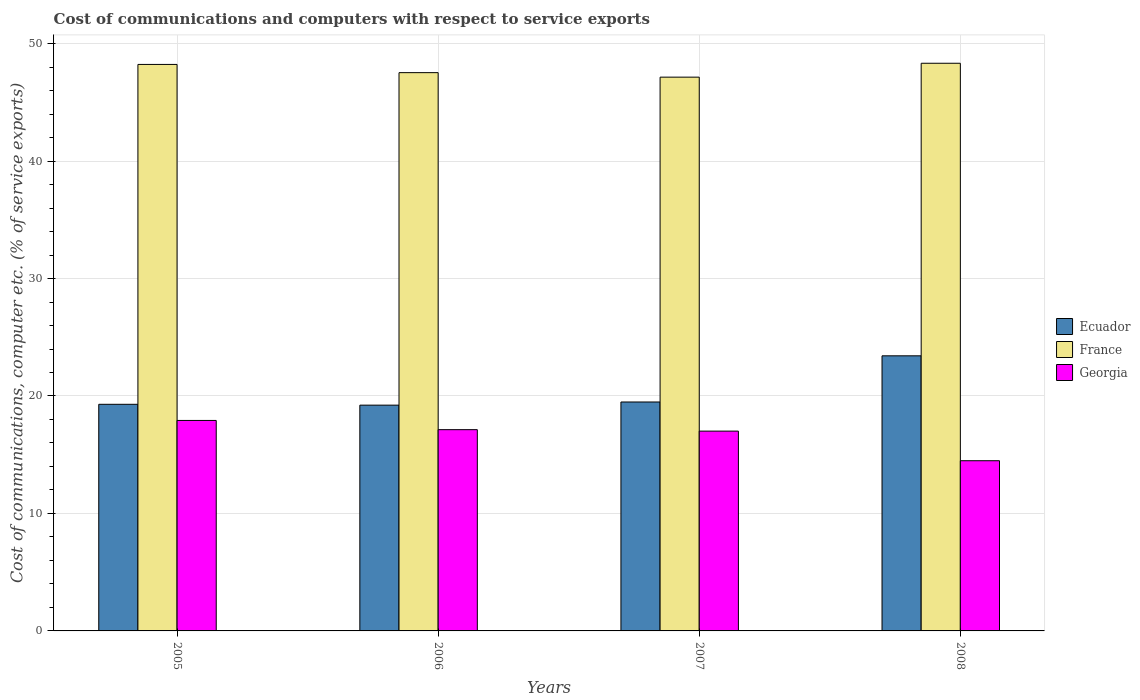How many different coloured bars are there?
Ensure brevity in your answer.  3. How many groups of bars are there?
Make the answer very short. 4. Are the number of bars per tick equal to the number of legend labels?
Offer a very short reply. Yes. In how many cases, is the number of bars for a given year not equal to the number of legend labels?
Make the answer very short. 0. What is the cost of communications and computers in Georgia in 2007?
Offer a very short reply. 17.01. Across all years, what is the maximum cost of communications and computers in Georgia?
Provide a short and direct response. 17.92. Across all years, what is the minimum cost of communications and computers in France?
Offer a terse response. 47.14. In which year was the cost of communications and computers in Ecuador minimum?
Offer a terse response. 2006. What is the total cost of communications and computers in Ecuador in the graph?
Your answer should be compact. 81.42. What is the difference between the cost of communications and computers in France in 2007 and that in 2008?
Ensure brevity in your answer.  -1.18. What is the difference between the cost of communications and computers in France in 2008 and the cost of communications and computers in Ecuador in 2005?
Offer a very short reply. 29.03. What is the average cost of communications and computers in Georgia per year?
Provide a short and direct response. 16.64. In the year 2007, what is the difference between the cost of communications and computers in Ecuador and cost of communications and computers in Georgia?
Provide a succinct answer. 2.48. What is the ratio of the cost of communications and computers in France in 2006 to that in 2008?
Give a very brief answer. 0.98. Is the cost of communications and computers in Georgia in 2005 less than that in 2006?
Your answer should be compact. No. Is the difference between the cost of communications and computers in Ecuador in 2005 and 2008 greater than the difference between the cost of communications and computers in Georgia in 2005 and 2008?
Offer a very short reply. No. What is the difference between the highest and the second highest cost of communications and computers in France?
Provide a succinct answer. 0.1. What is the difference between the highest and the lowest cost of communications and computers in Ecuador?
Make the answer very short. 4.2. In how many years, is the cost of communications and computers in France greater than the average cost of communications and computers in France taken over all years?
Your answer should be very brief. 2. Is the sum of the cost of communications and computers in Georgia in 2005 and 2006 greater than the maximum cost of communications and computers in France across all years?
Make the answer very short. No. What does the 2nd bar from the left in 2007 represents?
Keep it short and to the point. France. What does the 1st bar from the right in 2008 represents?
Provide a short and direct response. Georgia. Is it the case that in every year, the sum of the cost of communications and computers in France and cost of communications and computers in Georgia is greater than the cost of communications and computers in Ecuador?
Offer a very short reply. Yes. How many years are there in the graph?
Your answer should be very brief. 4. How are the legend labels stacked?
Make the answer very short. Vertical. What is the title of the graph?
Ensure brevity in your answer.  Cost of communications and computers with respect to service exports. Does "Barbados" appear as one of the legend labels in the graph?
Ensure brevity in your answer.  No. What is the label or title of the X-axis?
Offer a very short reply. Years. What is the label or title of the Y-axis?
Ensure brevity in your answer.  Cost of communications, computer etc. (% of service exports). What is the Cost of communications, computer etc. (% of service exports) in Ecuador in 2005?
Your answer should be very brief. 19.29. What is the Cost of communications, computer etc. (% of service exports) of France in 2005?
Your answer should be very brief. 48.23. What is the Cost of communications, computer etc. (% of service exports) of Georgia in 2005?
Offer a very short reply. 17.92. What is the Cost of communications, computer etc. (% of service exports) in Ecuador in 2006?
Give a very brief answer. 19.22. What is the Cost of communications, computer etc. (% of service exports) of France in 2006?
Make the answer very short. 47.53. What is the Cost of communications, computer etc. (% of service exports) of Georgia in 2006?
Your response must be concise. 17.13. What is the Cost of communications, computer etc. (% of service exports) of Ecuador in 2007?
Your answer should be very brief. 19.49. What is the Cost of communications, computer etc. (% of service exports) of France in 2007?
Keep it short and to the point. 47.14. What is the Cost of communications, computer etc. (% of service exports) of Georgia in 2007?
Provide a short and direct response. 17.01. What is the Cost of communications, computer etc. (% of service exports) in Ecuador in 2008?
Provide a short and direct response. 23.42. What is the Cost of communications, computer etc. (% of service exports) in France in 2008?
Provide a short and direct response. 48.33. What is the Cost of communications, computer etc. (% of service exports) in Georgia in 2008?
Give a very brief answer. 14.49. Across all years, what is the maximum Cost of communications, computer etc. (% of service exports) in Ecuador?
Keep it short and to the point. 23.42. Across all years, what is the maximum Cost of communications, computer etc. (% of service exports) in France?
Make the answer very short. 48.33. Across all years, what is the maximum Cost of communications, computer etc. (% of service exports) of Georgia?
Ensure brevity in your answer.  17.92. Across all years, what is the minimum Cost of communications, computer etc. (% of service exports) of Ecuador?
Provide a succinct answer. 19.22. Across all years, what is the minimum Cost of communications, computer etc. (% of service exports) of France?
Offer a terse response. 47.14. Across all years, what is the minimum Cost of communications, computer etc. (% of service exports) in Georgia?
Offer a very short reply. 14.49. What is the total Cost of communications, computer etc. (% of service exports) in Ecuador in the graph?
Provide a short and direct response. 81.42. What is the total Cost of communications, computer etc. (% of service exports) in France in the graph?
Keep it short and to the point. 191.22. What is the total Cost of communications, computer etc. (% of service exports) of Georgia in the graph?
Offer a very short reply. 66.55. What is the difference between the Cost of communications, computer etc. (% of service exports) in Ecuador in 2005 and that in 2006?
Your response must be concise. 0.07. What is the difference between the Cost of communications, computer etc. (% of service exports) in France in 2005 and that in 2006?
Your response must be concise. 0.7. What is the difference between the Cost of communications, computer etc. (% of service exports) in Georgia in 2005 and that in 2006?
Keep it short and to the point. 0.78. What is the difference between the Cost of communications, computer etc. (% of service exports) in Ecuador in 2005 and that in 2007?
Make the answer very short. -0.2. What is the difference between the Cost of communications, computer etc. (% of service exports) of France in 2005 and that in 2007?
Make the answer very short. 1.08. What is the difference between the Cost of communications, computer etc. (% of service exports) in Georgia in 2005 and that in 2007?
Your answer should be compact. 0.91. What is the difference between the Cost of communications, computer etc. (% of service exports) in Ecuador in 2005 and that in 2008?
Make the answer very short. -4.13. What is the difference between the Cost of communications, computer etc. (% of service exports) of France in 2005 and that in 2008?
Give a very brief answer. -0.1. What is the difference between the Cost of communications, computer etc. (% of service exports) of Georgia in 2005 and that in 2008?
Keep it short and to the point. 3.43. What is the difference between the Cost of communications, computer etc. (% of service exports) in Ecuador in 2006 and that in 2007?
Make the answer very short. -0.27. What is the difference between the Cost of communications, computer etc. (% of service exports) in France in 2006 and that in 2007?
Keep it short and to the point. 0.38. What is the difference between the Cost of communications, computer etc. (% of service exports) in Georgia in 2006 and that in 2007?
Ensure brevity in your answer.  0.12. What is the difference between the Cost of communications, computer etc. (% of service exports) in Ecuador in 2006 and that in 2008?
Your answer should be very brief. -4.2. What is the difference between the Cost of communications, computer etc. (% of service exports) of France in 2006 and that in 2008?
Make the answer very short. -0.8. What is the difference between the Cost of communications, computer etc. (% of service exports) of Georgia in 2006 and that in 2008?
Ensure brevity in your answer.  2.65. What is the difference between the Cost of communications, computer etc. (% of service exports) in Ecuador in 2007 and that in 2008?
Offer a very short reply. -3.93. What is the difference between the Cost of communications, computer etc. (% of service exports) of France in 2007 and that in 2008?
Provide a succinct answer. -1.18. What is the difference between the Cost of communications, computer etc. (% of service exports) of Georgia in 2007 and that in 2008?
Your answer should be compact. 2.52. What is the difference between the Cost of communications, computer etc. (% of service exports) in Ecuador in 2005 and the Cost of communications, computer etc. (% of service exports) in France in 2006?
Ensure brevity in your answer.  -28.23. What is the difference between the Cost of communications, computer etc. (% of service exports) in Ecuador in 2005 and the Cost of communications, computer etc. (% of service exports) in Georgia in 2006?
Provide a short and direct response. 2.16. What is the difference between the Cost of communications, computer etc. (% of service exports) in France in 2005 and the Cost of communications, computer etc. (% of service exports) in Georgia in 2006?
Give a very brief answer. 31.09. What is the difference between the Cost of communications, computer etc. (% of service exports) in Ecuador in 2005 and the Cost of communications, computer etc. (% of service exports) in France in 2007?
Your answer should be very brief. -27.85. What is the difference between the Cost of communications, computer etc. (% of service exports) of Ecuador in 2005 and the Cost of communications, computer etc. (% of service exports) of Georgia in 2007?
Your answer should be very brief. 2.28. What is the difference between the Cost of communications, computer etc. (% of service exports) in France in 2005 and the Cost of communications, computer etc. (% of service exports) in Georgia in 2007?
Give a very brief answer. 31.22. What is the difference between the Cost of communications, computer etc. (% of service exports) in Ecuador in 2005 and the Cost of communications, computer etc. (% of service exports) in France in 2008?
Your response must be concise. -29.03. What is the difference between the Cost of communications, computer etc. (% of service exports) of Ecuador in 2005 and the Cost of communications, computer etc. (% of service exports) of Georgia in 2008?
Keep it short and to the point. 4.8. What is the difference between the Cost of communications, computer etc. (% of service exports) of France in 2005 and the Cost of communications, computer etc. (% of service exports) of Georgia in 2008?
Provide a succinct answer. 33.74. What is the difference between the Cost of communications, computer etc. (% of service exports) of Ecuador in 2006 and the Cost of communications, computer etc. (% of service exports) of France in 2007?
Your answer should be compact. -27.92. What is the difference between the Cost of communications, computer etc. (% of service exports) of Ecuador in 2006 and the Cost of communications, computer etc. (% of service exports) of Georgia in 2007?
Make the answer very short. 2.21. What is the difference between the Cost of communications, computer etc. (% of service exports) of France in 2006 and the Cost of communications, computer etc. (% of service exports) of Georgia in 2007?
Provide a succinct answer. 30.52. What is the difference between the Cost of communications, computer etc. (% of service exports) in Ecuador in 2006 and the Cost of communications, computer etc. (% of service exports) in France in 2008?
Provide a short and direct response. -29.11. What is the difference between the Cost of communications, computer etc. (% of service exports) in Ecuador in 2006 and the Cost of communications, computer etc. (% of service exports) in Georgia in 2008?
Your answer should be compact. 4.73. What is the difference between the Cost of communications, computer etc. (% of service exports) of France in 2006 and the Cost of communications, computer etc. (% of service exports) of Georgia in 2008?
Your answer should be very brief. 33.04. What is the difference between the Cost of communications, computer etc. (% of service exports) of Ecuador in 2007 and the Cost of communications, computer etc. (% of service exports) of France in 2008?
Offer a terse response. -28.84. What is the difference between the Cost of communications, computer etc. (% of service exports) of Ecuador in 2007 and the Cost of communications, computer etc. (% of service exports) of Georgia in 2008?
Your answer should be compact. 5. What is the difference between the Cost of communications, computer etc. (% of service exports) of France in 2007 and the Cost of communications, computer etc. (% of service exports) of Georgia in 2008?
Ensure brevity in your answer.  32.66. What is the average Cost of communications, computer etc. (% of service exports) of Ecuador per year?
Give a very brief answer. 20.36. What is the average Cost of communications, computer etc. (% of service exports) in France per year?
Make the answer very short. 47.81. What is the average Cost of communications, computer etc. (% of service exports) of Georgia per year?
Keep it short and to the point. 16.64. In the year 2005, what is the difference between the Cost of communications, computer etc. (% of service exports) in Ecuador and Cost of communications, computer etc. (% of service exports) in France?
Give a very brief answer. -28.93. In the year 2005, what is the difference between the Cost of communications, computer etc. (% of service exports) of Ecuador and Cost of communications, computer etc. (% of service exports) of Georgia?
Give a very brief answer. 1.37. In the year 2005, what is the difference between the Cost of communications, computer etc. (% of service exports) of France and Cost of communications, computer etc. (% of service exports) of Georgia?
Offer a terse response. 30.31. In the year 2006, what is the difference between the Cost of communications, computer etc. (% of service exports) of Ecuador and Cost of communications, computer etc. (% of service exports) of France?
Your answer should be very brief. -28.31. In the year 2006, what is the difference between the Cost of communications, computer etc. (% of service exports) of Ecuador and Cost of communications, computer etc. (% of service exports) of Georgia?
Keep it short and to the point. 2.09. In the year 2006, what is the difference between the Cost of communications, computer etc. (% of service exports) of France and Cost of communications, computer etc. (% of service exports) of Georgia?
Give a very brief answer. 30.39. In the year 2007, what is the difference between the Cost of communications, computer etc. (% of service exports) of Ecuador and Cost of communications, computer etc. (% of service exports) of France?
Your answer should be very brief. -27.65. In the year 2007, what is the difference between the Cost of communications, computer etc. (% of service exports) of Ecuador and Cost of communications, computer etc. (% of service exports) of Georgia?
Offer a very short reply. 2.48. In the year 2007, what is the difference between the Cost of communications, computer etc. (% of service exports) in France and Cost of communications, computer etc. (% of service exports) in Georgia?
Make the answer very short. 30.13. In the year 2008, what is the difference between the Cost of communications, computer etc. (% of service exports) of Ecuador and Cost of communications, computer etc. (% of service exports) of France?
Provide a short and direct response. -24.91. In the year 2008, what is the difference between the Cost of communications, computer etc. (% of service exports) in Ecuador and Cost of communications, computer etc. (% of service exports) in Georgia?
Your answer should be compact. 8.93. In the year 2008, what is the difference between the Cost of communications, computer etc. (% of service exports) of France and Cost of communications, computer etc. (% of service exports) of Georgia?
Provide a short and direct response. 33.84. What is the ratio of the Cost of communications, computer etc. (% of service exports) in France in 2005 to that in 2006?
Make the answer very short. 1.01. What is the ratio of the Cost of communications, computer etc. (% of service exports) in Georgia in 2005 to that in 2006?
Offer a very short reply. 1.05. What is the ratio of the Cost of communications, computer etc. (% of service exports) of Ecuador in 2005 to that in 2007?
Offer a very short reply. 0.99. What is the ratio of the Cost of communications, computer etc. (% of service exports) of France in 2005 to that in 2007?
Provide a short and direct response. 1.02. What is the ratio of the Cost of communications, computer etc. (% of service exports) in Georgia in 2005 to that in 2007?
Your answer should be compact. 1.05. What is the ratio of the Cost of communications, computer etc. (% of service exports) in Ecuador in 2005 to that in 2008?
Give a very brief answer. 0.82. What is the ratio of the Cost of communications, computer etc. (% of service exports) of Georgia in 2005 to that in 2008?
Provide a short and direct response. 1.24. What is the ratio of the Cost of communications, computer etc. (% of service exports) of Ecuador in 2006 to that in 2007?
Offer a very short reply. 0.99. What is the ratio of the Cost of communications, computer etc. (% of service exports) in Georgia in 2006 to that in 2007?
Provide a short and direct response. 1.01. What is the ratio of the Cost of communications, computer etc. (% of service exports) in Ecuador in 2006 to that in 2008?
Give a very brief answer. 0.82. What is the ratio of the Cost of communications, computer etc. (% of service exports) of France in 2006 to that in 2008?
Give a very brief answer. 0.98. What is the ratio of the Cost of communications, computer etc. (% of service exports) in Georgia in 2006 to that in 2008?
Give a very brief answer. 1.18. What is the ratio of the Cost of communications, computer etc. (% of service exports) of Ecuador in 2007 to that in 2008?
Your answer should be very brief. 0.83. What is the ratio of the Cost of communications, computer etc. (% of service exports) in France in 2007 to that in 2008?
Your answer should be very brief. 0.98. What is the ratio of the Cost of communications, computer etc. (% of service exports) in Georgia in 2007 to that in 2008?
Ensure brevity in your answer.  1.17. What is the difference between the highest and the second highest Cost of communications, computer etc. (% of service exports) in Ecuador?
Your answer should be very brief. 3.93. What is the difference between the highest and the second highest Cost of communications, computer etc. (% of service exports) in France?
Give a very brief answer. 0.1. What is the difference between the highest and the second highest Cost of communications, computer etc. (% of service exports) in Georgia?
Ensure brevity in your answer.  0.78. What is the difference between the highest and the lowest Cost of communications, computer etc. (% of service exports) of Ecuador?
Your answer should be very brief. 4.2. What is the difference between the highest and the lowest Cost of communications, computer etc. (% of service exports) in France?
Offer a terse response. 1.18. What is the difference between the highest and the lowest Cost of communications, computer etc. (% of service exports) of Georgia?
Offer a very short reply. 3.43. 